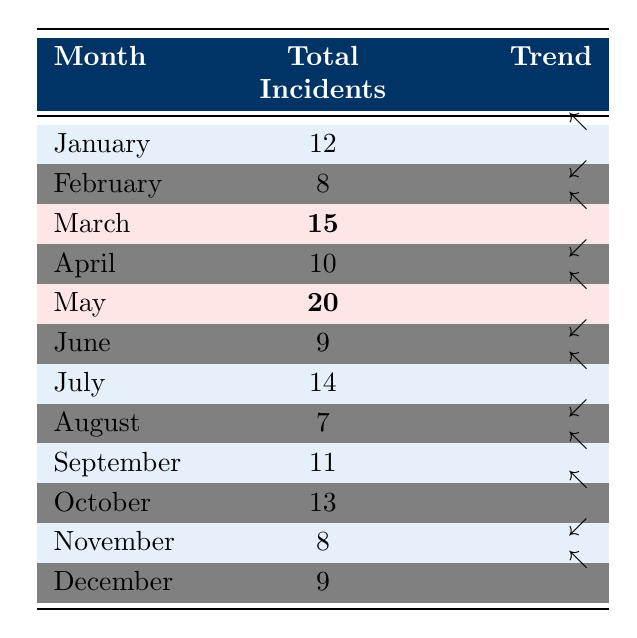What was the month with the highest number of unauthorized access incidents? The table shows that May had the highest number of incidents with a total of 20.
Answer: May How many total unauthorized access incidents were reported in the first half of 2023 (January to June)? Adding the total incidents from January (12), February (8), March (15), April (10), May (20), and June (9) gives 12 + 8 + 15 + 10 + 20 + 9 = 74.
Answer: 74 Was there an increase or decrease in incidents from April to May? April had 10 incidents and May had 20, which is an increase from April to May (10 to 20).
Answer: Increase How many incidents occurred in June, July, and August combined? June had 9 incidents, July had 14, and August had 7. Adding these together: 9 + 14 + 7 = 30.
Answer: 30 In which month did unauthorized access incidents peak in 2023 according to the table? The peak was in May with a total of 20 reported incidents.
Answer: May How many months had total incidents greater than 10? The months with incidents greater than 10 are January (12), March (15), May (20), July (14), September (11), and October (13). That totals 6 months.
Answer: 6 What is the total number of incidents recorded in November and December? November had 8 incidents and December had 9, so the total for those two months is 8 + 9 = 17.
Answer: 17 Which month saw a return to incidents above 10 after August? September had 11 incidents, returning above the threshold after August, which had 7 incidents.
Answer: September What was the trend direction for the incidents from March to June? From March (15 incidents) to June (9 incidents), the trend was downward (15 to 9).
Answer: Downward Did the total unauthorized access incidents in October surpass those in January? October had 13 incidents, while January had 12 incidents, hence October did surpass January.
Answer: Yes How many unique incident methods were reported in the first quarter (Q1) of 2023? The unique methods reported in Q1 (January to March) are Phishing Attack, Credential Stuffing, Physical Breach, and Social Engineering, totaling 4 unique methods.
Answer: 4 What was the average number of incidents reported per month from July to September? The total incidents in July (14), August (7), and September (11) is 14 + 7 + 11 = 32. Dividing by 3 months gives us an average of 32/3 = 10.67.
Answer: 10.67 (approximately 11) 